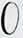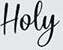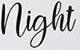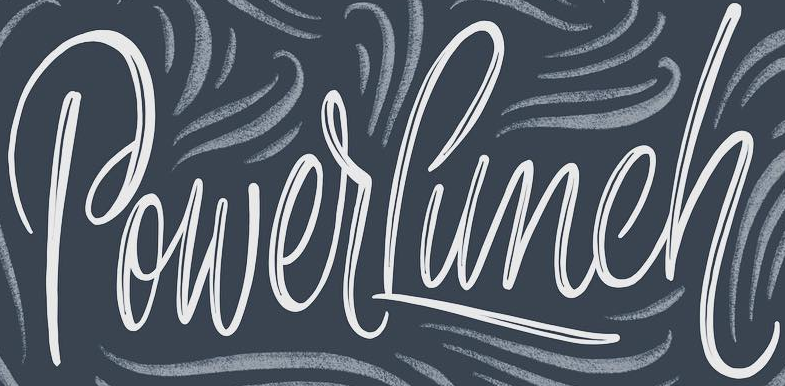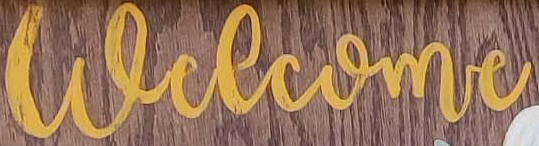Identify the words shown in these images in order, separated by a semicolon. O; Hoey; night; PowerLunch; welcome 